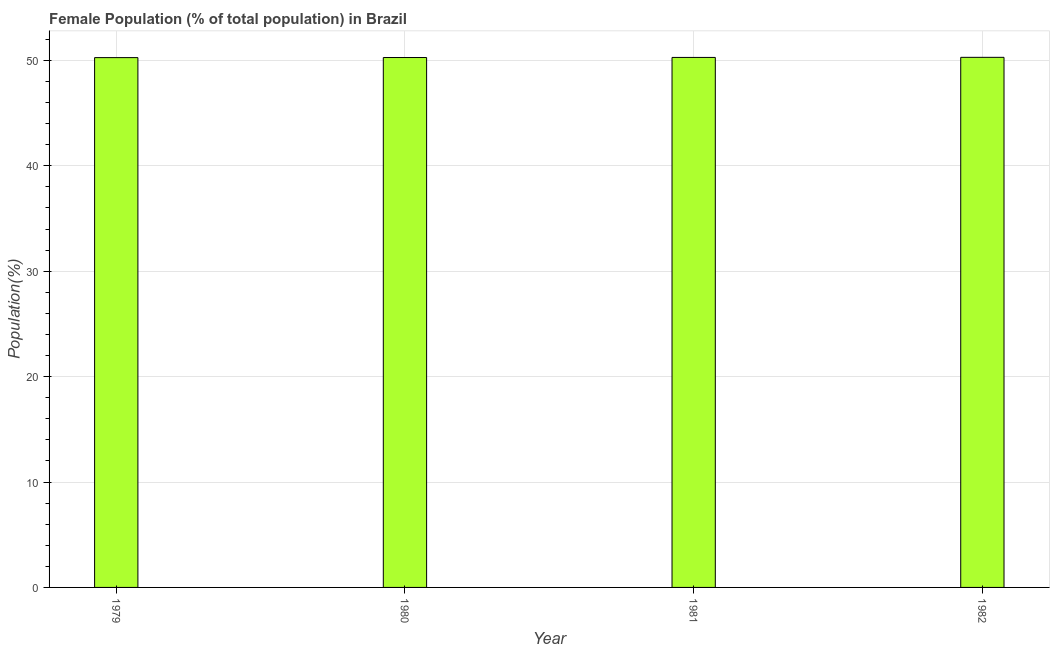Does the graph contain any zero values?
Give a very brief answer. No. Does the graph contain grids?
Your answer should be compact. Yes. What is the title of the graph?
Your answer should be very brief. Female Population (% of total population) in Brazil. What is the label or title of the Y-axis?
Provide a succinct answer. Population(%). What is the female population in 1980?
Make the answer very short. 50.27. Across all years, what is the maximum female population?
Give a very brief answer. 50.29. Across all years, what is the minimum female population?
Offer a terse response. 50.27. In which year was the female population maximum?
Give a very brief answer. 1982. In which year was the female population minimum?
Ensure brevity in your answer.  1979. What is the sum of the female population?
Make the answer very short. 201.11. What is the difference between the female population in 1980 and 1982?
Make the answer very short. -0.02. What is the average female population per year?
Your answer should be very brief. 50.28. What is the median female population?
Offer a terse response. 50.28. In how many years, is the female population greater than 42 %?
Your answer should be very brief. 4. What is the ratio of the female population in 1979 to that in 1980?
Provide a short and direct response. 1. Is the difference between the female population in 1981 and 1982 greater than the difference between any two years?
Your answer should be compact. No. What is the difference between the highest and the second highest female population?
Ensure brevity in your answer.  0.01. Is the sum of the female population in 1979 and 1982 greater than the maximum female population across all years?
Your answer should be compact. Yes. What is the difference between the highest and the lowest female population?
Provide a succinct answer. 0.03. How many years are there in the graph?
Your answer should be compact. 4. Are the values on the major ticks of Y-axis written in scientific E-notation?
Offer a terse response. No. What is the Population(%) of 1979?
Provide a short and direct response. 50.27. What is the Population(%) in 1980?
Your answer should be very brief. 50.27. What is the Population(%) of 1981?
Provide a short and direct response. 50.28. What is the Population(%) in 1982?
Your response must be concise. 50.29. What is the difference between the Population(%) in 1979 and 1980?
Give a very brief answer. -0.01. What is the difference between the Population(%) in 1979 and 1981?
Give a very brief answer. -0.02. What is the difference between the Population(%) in 1979 and 1982?
Your answer should be compact. -0.03. What is the difference between the Population(%) in 1980 and 1981?
Your response must be concise. -0.01. What is the difference between the Population(%) in 1980 and 1982?
Offer a terse response. -0.02. What is the difference between the Population(%) in 1981 and 1982?
Keep it short and to the point. -0.01. What is the ratio of the Population(%) in 1979 to that in 1980?
Keep it short and to the point. 1. What is the ratio of the Population(%) in 1980 to that in 1981?
Ensure brevity in your answer.  1. What is the ratio of the Population(%) in 1980 to that in 1982?
Give a very brief answer. 1. 